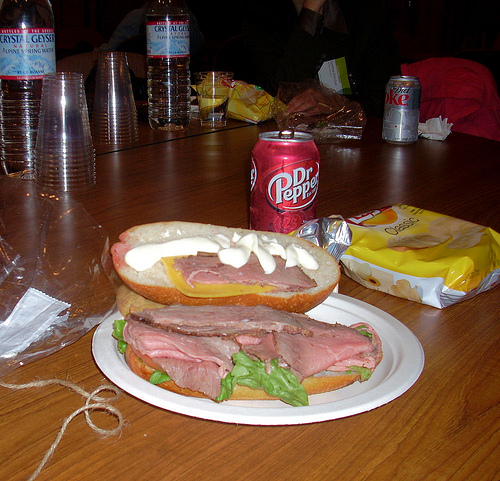Please extract the text content from this image. Dr Dr Pepper i i i i i CRYSTAL 